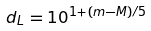<formula> <loc_0><loc_0><loc_500><loc_500>d _ { L } = 1 0 ^ { 1 + ( m - M ) / 5 }</formula> 